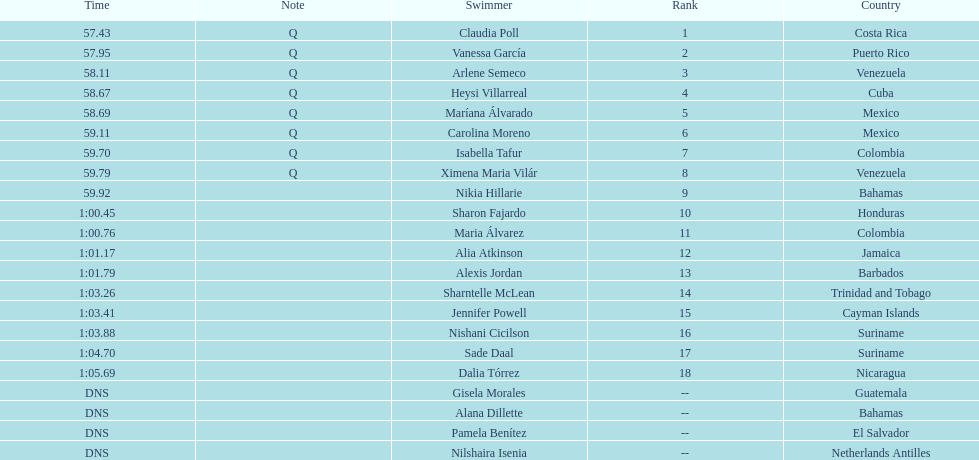How many swimmers had a time of at least 1:00 9. Write the full table. {'header': ['Time', 'Note', 'Swimmer', 'Rank', 'Country'], 'rows': [['57.43', 'Q', 'Claudia Poll', '1', 'Costa Rica'], ['57.95', 'Q', 'Vanessa García', '2', 'Puerto Rico'], ['58.11', 'Q', 'Arlene Semeco', '3', 'Venezuela'], ['58.67', 'Q', 'Heysi Villarreal', '4', 'Cuba'], ['58.69', 'Q', 'Maríana Álvarado', '5', 'Mexico'], ['59.11', 'Q', 'Carolina Moreno', '6', 'Mexico'], ['59.70', 'Q', 'Isabella Tafur', '7', 'Colombia'], ['59.79', 'Q', 'Ximena Maria Vilár', '8', 'Venezuela'], ['59.92', '', 'Nikia Hillarie', '9', 'Bahamas'], ['1:00.45', '', 'Sharon Fajardo', '10', 'Honduras'], ['1:00.76', '', 'Maria Álvarez', '11', 'Colombia'], ['1:01.17', '', 'Alia Atkinson', '12', 'Jamaica'], ['1:01.79', '', 'Alexis Jordan', '13', 'Barbados'], ['1:03.26', '', 'Sharntelle McLean', '14', 'Trinidad and Tobago'], ['1:03.41', '', 'Jennifer Powell', '15', 'Cayman Islands'], ['1:03.88', '', 'Nishani Cicilson', '16', 'Suriname'], ['1:04.70', '', 'Sade Daal', '17', 'Suriname'], ['1:05.69', '', 'Dalia Tórrez', '18', 'Nicaragua'], ['DNS', '', 'Gisela Morales', '--', 'Guatemala'], ['DNS', '', 'Alana Dillette', '--', 'Bahamas'], ['DNS', '', 'Pamela Benítez', '--', 'El Salvador'], ['DNS', '', 'Nilshaira Isenia', '--', 'Netherlands Antilles']]} 